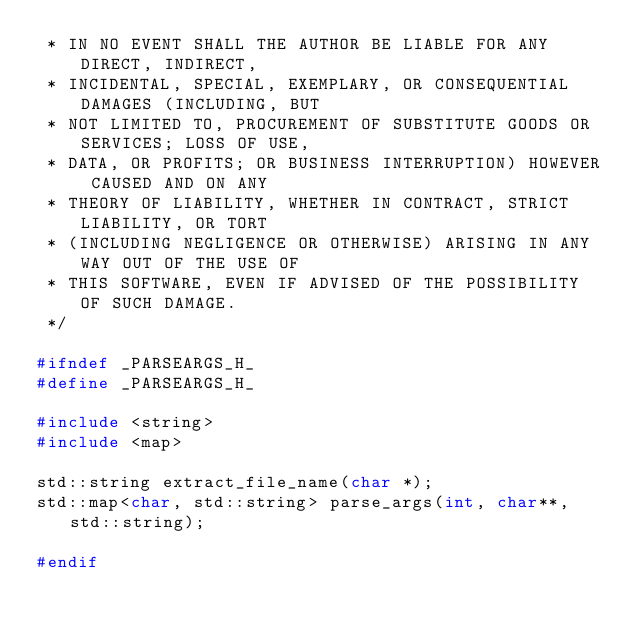Convert code to text. <code><loc_0><loc_0><loc_500><loc_500><_C++_> * IN NO EVENT SHALL THE AUTHOR BE LIABLE FOR ANY DIRECT, INDIRECT,
 * INCIDENTAL, SPECIAL, EXEMPLARY, OR CONSEQUENTIAL DAMAGES (INCLUDING, BUT
 * NOT LIMITED TO, PROCUREMENT OF SUBSTITUTE GOODS OR SERVICES; LOSS OF USE,
 * DATA, OR PROFITS; OR BUSINESS INTERRUPTION) HOWEVER CAUSED AND ON ANY
 * THEORY OF LIABILITY, WHETHER IN CONTRACT, STRICT LIABILITY, OR TORT
 * (INCLUDING NEGLIGENCE OR OTHERWISE) ARISING IN ANY WAY OUT OF THE USE OF
 * THIS SOFTWARE, EVEN IF ADVISED OF THE POSSIBILITY OF SUCH DAMAGE.
 */

#ifndef _PARSEARGS_H_ 
#define _PARSEARGS_H_

#include <string>
#include <map>

std::string extract_file_name(char *); 
std::map<char, std::string> parse_args(int, char**, std::string);

#endif</code> 